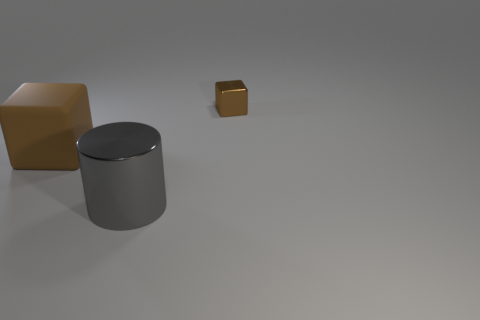Is there a large object made of the same material as the small brown object?
Provide a succinct answer. Yes. Is the shape of the rubber object the same as the brown thing behind the big rubber block?
Give a very brief answer. Yes. How many cubes are both to the left of the tiny thing and to the right of the gray cylinder?
Offer a terse response. 0. Is the tiny brown cube made of the same material as the object that is left of the big metallic object?
Provide a short and direct response. No. Is the number of gray metallic objects behind the brown matte object the same as the number of big cubes?
Your answer should be compact. No. There is a metallic object in front of the tiny brown cube; what is its color?
Ensure brevity in your answer.  Gray. What number of other things are the same color as the big metallic thing?
Provide a short and direct response. 0. Is there any other thing that has the same size as the metal block?
Your answer should be very brief. No. There is a metal thing that is in front of the brown rubber object; is it the same size as the small metal block?
Provide a short and direct response. No. What material is the brown object on the left side of the gray metal thing?
Keep it short and to the point. Rubber. 